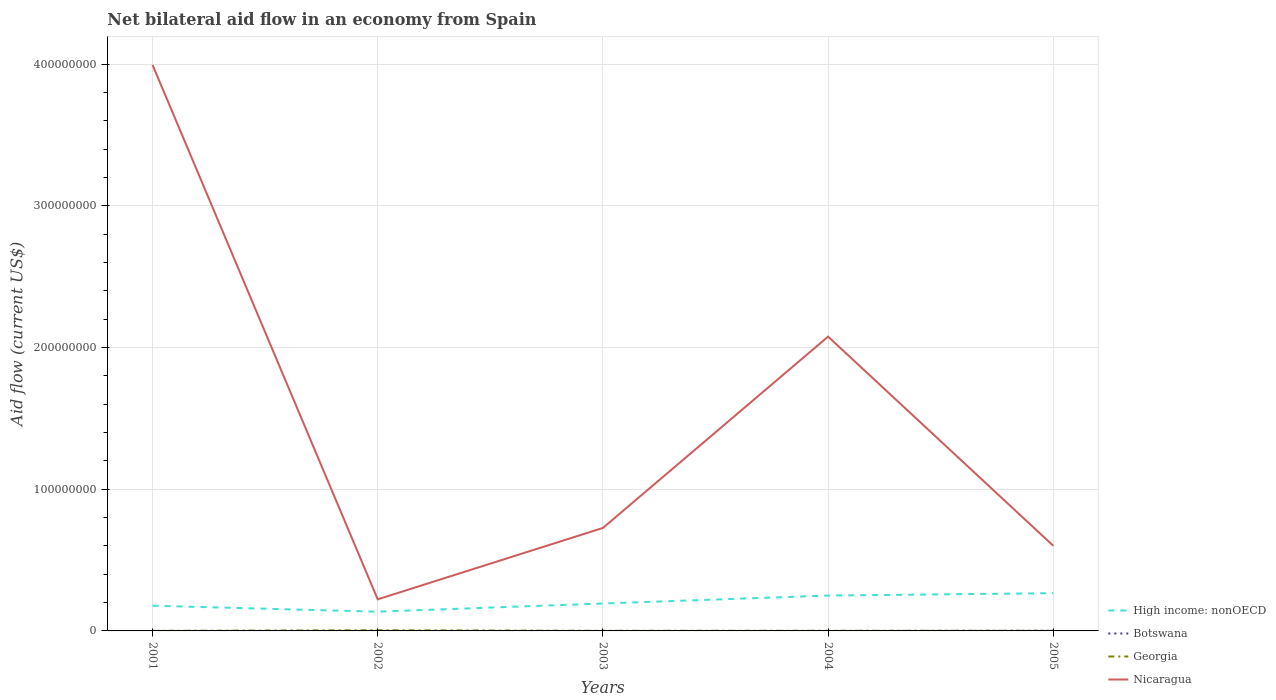How many different coloured lines are there?
Your answer should be compact. 4. Does the line corresponding to Georgia intersect with the line corresponding to High income: nonOECD?
Your answer should be compact. No. Across all years, what is the maximum net bilateral aid flow in Nicaragua?
Provide a short and direct response. 2.23e+07. In which year was the net bilateral aid flow in High income: nonOECD maximum?
Offer a very short reply. 2002. What is the total net bilateral aid flow in Nicaragua in the graph?
Your answer should be compact. -5.04e+07. What is the difference between the highest and the second highest net bilateral aid flow in Georgia?
Your answer should be compact. 4.10e+05. How many lines are there?
Your response must be concise. 4. What is the difference between two consecutive major ticks on the Y-axis?
Your answer should be very brief. 1.00e+08. Are the values on the major ticks of Y-axis written in scientific E-notation?
Provide a short and direct response. No. Does the graph contain grids?
Provide a succinct answer. Yes. How many legend labels are there?
Your answer should be very brief. 4. What is the title of the graph?
Give a very brief answer. Net bilateral aid flow in an economy from Spain. What is the label or title of the Y-axis?
Ensure brevity in your answer.  Aid flow (current US$). What is the Aid flow (current US$) of High income: nonOECD in 2001?
Offer a terse response. 1.78e+07. What is the Aid flow (current US$) of Botswana in 2001?
Your response must be concise. 10000. What is the Aid flow (current US$) in Georgia in 2001?
Keep it short and to the point. 5.00e+04. What is the Aid flow (current US$) of Nicaragua in 2001?
Your response must be concise. 3.99e+08. What is the Aid flow (current US$) of High income: nonOECD in 2002?
Your answer should be compact. 1.36e+07. What is the Aid flow (current US$) of Nicaragua in 2002?
Offer a very short reply. 2.23e+07. What is the Aid flow (current US$) of High income: nonOECD in 2003?
Offer a terse response. 1.94e+07. What is the Aid flow (current US$) of Georgia in 2003?
Keep it short and to the point. 8.00e+04. What is the Aid flow (current US$) of Nicaragua in 2003?
Provide a succinct answer. 7.27e+07. What is the Aid flow (current US$) of High income: nonOECD in 2004?
Offer a very short reply. 2.50e+07. What is the Aid flow (current US$) in Georgia in 2004?
Offer a terse response. 9.00e+04. What is the Aid flow (current US$) of Nicaragua in 2004?
Offer a terse response. 2.08e+08. What is the Aid flow (current US$) in High income: nonOECD in 2005?
Make the answer very short. 2.66e+07. What is the Aid flow (current US$) of Botswana in 2005?
Your answer should be compact. 1.50e+05. What is the Aid flow (current US$) of Nicaragua in 2005?
Make the answer very short. 6.01e+07. Across all years, what is the maximum Aid flow (current US$) in High income: nonOECD?
Your answer should be compact. 2.66e+07. Across all years, what is the maximum Aid flow (current US$) in Georgia?
Provide a succinct answer. 4.60e+05. Across all years, what is the maximum Aid flow (current US$) in Nicaragua?
Provide a succinct answer. 3.99e+08. Across all years, what is the minimum Aid flow (current US$) of High income: nonOECD?
Provide a short and direct response. 1.36e+07. Across all years, what is the minimum Aid flow (current US$) in Nicaragua?
Offer a very short reply. 2.23e+07. What is the total Aid flow (current US$) of High income: nonOECD in the graph?
Give a very brief answer. 1.02e+08. What is the total Aid flow (current US$) of Botswana in the graph?
Offer a terse response. 1.90e+05. What is the total Aid flow (current US$) of Georgia in the graph?
Offer a very short reply. 7.80e+05. What is the total Aid flow (current US$) in Nicaragua in the graph?
Make the answer very short. 7.62e+08. What is the difference between the Aid flow (current US$) of High income: nonOECD in 2001 and that in 2002?
Your answer should be compact. 4.22e+06. What is the difference between the Aid flow (current US$) in Botswana in 2001 and that in 2002?
Give a very brief answer. 0. What is the difference between the Aid flow (current US$) of Georgia in 2001 and that in 2002?
Your answer should be very brief. -4.10e+05. What is the difference between the Aid flow (current US$) in Nicaragua in 2001 and that in 2002?
Ensure brevity in your answer.  3.77e+08. What is the difference between the Aid flow (current US$) of High income: nonOECD in 2001 and that in 2003?
Provide a short and direct response. -1.57e+06. What is the difference between the Aid flow (current US$) in Nicaragua in 2001 and that in 2003?
Your answer should be compact. 3.27e+08. What is the difference between the Aid flow (current US$) in High income: nonOECD in 2001 and that in 2004?
Your answer should be compact. -7.16e+06. What is the difference between the Aid flow (current US$) of Botswana in 2001 and that in 2004?
Provide a succinct answer. 0. What is the difference between the Aid flow (current US$) in Nicaragua in 2001 and that in 2004?
Your answer should be very brief. 1.92e+08. What is the difference between the Aid flow (current US$) in High income: nonOECD in 2001 and that in 2005?
Make the answer very short. -8.86e+06. What is the difference between the Aid flow (current US$) of Botswana in 2001 and that in 2005?
Your answer should be compact. -1.40e+05. What is the difference between the Aid flow (current US$) in Georgia in 2001 and that in 2005?
Your response must be concise. -5.00e+04. What is the difference between the Aid flow (current US$) of Nicaragua in 2001 and that in 2005?
Provide a succinct answer. 3.39e+08. What is the difference between the Aid flow (current US$) of High income: nonOECD in 2002 and that in 2003?
Provide a succinct answer. -5.79e+06. What is the difference between the Aid flow (current US$) in Botswana in 2002 and that in 2003?
Provide a succinct answer. 0. What is the difference between the Aid flow (current US$) of Georgia in 2002 and that in 2003?
Provide a succinct answer. 3.80e+05. What is the difference between the Aid flow (current US$) in Nicaragua in 2002 and that in 2003?
Give a very brief answer. -5.04e+07. What is the difference between the Aid flow (current US$) of High income: nonOECD in 2002 and that in 2004?
Make the answer very short. -1.14e+07. What is the difference between the Aid flow (current US$) in Botswana in 2002 and that in 2004?
Provide a short and direct response. 0. What is the difference between the Aid flow (current US$) in Georgia in 2002 and that in 2004?
Your answer should be compact. 3.70e+05. What is the difference between the Aid flow (current US$) of Nicaragua in 2002 and that in 2004?
Your answer should be very brief. -1.85e+08. What is the difference between the Aid flow (current US$) in High income: nonOECD in 2002 and that in 2005?
Offer a terse response. -1.31e+07. What is the difference between the Aid flow (current US$) of Nicaragua in 2002 and that in 2005?
Your answer should be very brief. -3.78e+07. What is the difference between the Aid flow (current US$) in High income: nonOECD in 2003 and that in 2004?
Your response must be concise. -5.59e+06. What is the difference between the Aid flow (current US$) in Nicaragua in 2003 and that in 2004?
Provide a short and direct response. -1.35e+08. What is the difference between the Aid flow (current US$) in High income: nonOECD in 2003 and that in 2005?
Make the answer very short. -7.29e+06. What is the difference between the Aid flow (current US$) in Botswana in 2003 and that in 2005?
Offer a terse response. -1.40e+05. What is the difference between the Aid flow (current US$) in Nicaragua in 2003 and that in 2005?
Offer a very short reply. 1.26e+07. What is the difference between the Aid flow (current US$) of High income: nonOECD in 2004 and that in 2005?
Offer a very short reply. -1.70e+06. What is the difference between the Aid flow (current US$) of Botswana in 2004 and that in 2005?
Ensure brevity in your answer.  -1.40e+05. What is the difference between the Aid flow (current US$) of Georgia in 2004 and that in 2005?
Your answer should be very brief. -10000. What is the difference between the Aid flow (current US$) in Nicaragua in 2004 and that in 2005?
Ensure brevity in your answer.  1.48e+08. What is the difference between the Aid flow (current US$) in High income: nonOECD in 2001 and the Aid flow (current US$) in Botswana in 2002?
Ensure brevity in your answer.  1.78e+07. What is the difference between the Aid flow (current US$) in High income: nonOECD in 2001 and the Aid flow (current US$) in Georgia in 2002?
Your answer should be very brief. 1.73e+07. What is the difference between the Aid flow (current US$) in High income: nonOECD in 2001 and the Aid flow (current US$) in Nicaragua in 2002?
Ensure brevity in your answer.  -4.50e+06. What is the difference between the Aid flow (current US$) of Botswana in 2001 and the Aid flow (current US$) of Georgia in 2002?
Keep it short and to the point. -4.50e+05. What is the difference between the Aid flow (current US$) in Botswana in 2001 and the Aid flow (current US$) in Nicaragua in 2002?
Keep it short and to the point. -2.23e+07. What is the difference between the Aid flow (current US$) of Georgia in 2001 and the Aid flow (current US$) of Nicaragua in 2002?
Your answer should be compact. -2.22e+07. What is the difference between the Aid flow (current US$) in High income: nonOECD in 2001 and the Aid flow (current US$) in Botswana in 2003?
Ensure brevity in your answer.  1.78e+07. What is the difference between the Aid flow (current US$) of High income: nonOECD in 2001 and the Aid flow (current US$) of Georgia in 2003?
Give a very brief answer. 1.77e+07. What is the difference between the Aid flow (current US$) in High income: nonOECD in 2001 and the Aid flow (current US$) in Nicaragua in 2003?
Your response must be concise. -5.49e+07. What is the difference between the Aid flow (current US$) in Botswana in 2001 and the Aid flow (current US$) in Nicaragua in 2003?
Your answer should be very brief. -7.27e+07. What is the difference between the Aid flow (current US$) in Georgia in 2001 and the Aid flow (current US$) in Nicaragua in 2003?
Give a very brief answer. -7.26e+07. What is the difference between the Aid flow (current US$) in High income: nonOECD in 2001 and the Aid flow (current US$) in Botswana in 2004?
Ensure brevity in your answer.  1.78e+07. What is the difference between the Aid flow (current US$) in High income: nonOECD in 2001 and the Aid flow (current US$) in Georgia in 2004?
Ensure brevity in your answer.  1.77e+07. What is the difference between the Aid flow (current US$) in High income: nonOECD in 2001 and the Aid flow (current US$) in Nicaragua in 2004?
Provide a short and direct response. -1.90e+08. What is the difference between the Aid flow (current US$) of Botswana in 2001 and the Aid flow (current US$) of Nicaragua in 2004?
Provide a short and direct response. -2.08e+08. What is the difference between the Aid flow (current US$) in Georgia in 2001 and the Aid flow (current US$) in Nicaragua in 2004?
Give a very brief answer. -2.08e+08. What is the difference between the Aid flow (current US$) in High income: nonOECD in 2001 and the Aid flow (current US$) in Botswana in 2005?
Keep it short and to the point. 1.76e+07. What is the difference between the Aid flow (current US$) of High income: nonOECD in 2001 and the Aid flow (current US$) of Georgia in 2005?
Provide a short and direct response. 1.77e+07. What is the difference between the Aid flow (current US$) in High income: nonOECD in 2001 and the Aid flow (current US$) in Nicaragua in 2005?
Give a very brief answer. -4.23e+07. What is the difference between the Aid flow (current US$) of Botswana in 2001 and the Aid flow (current US$) of Georgia in 2005?
Your answer should be compact. -9.00e+04. What is the difference between the Aid flow (current US$) of Botswana in 2001 and the Aid flow (current US$) of Nicaragua in 2005?
Offer a terse response. -6.01e+07. What is the difference between the Aid flow (current US$) of Georgia in 2001 and the Aid flow (current US$) of Nicaragua in 2005?
Make the answer very short. -6.00e+07. What is the difference between the Aid flow (current US$) of High income: nonOECD in 2002 and the Aid flow (current US$) of Botswana in 2003?
Offer a terse response. 1.36e+07. What is the difference between the Aid flow (current US$) of High income: nonOECD in 2002 and the Aid flow (current US$) of Georgia in 2003?
Provide a succinct answer. 1.35e+07. What is the difference between the Aid flow (current US$) of High income: nonOECD in 2002 and the Aid flow (current US$) of Nicaragua in 2003?
Provide a short and direct response. -5.91e+07. What is the difference between the Aid flow (current US$) of Botswana in 2002 and the Aid flow (current US$) of Nicaragua in 2003?
Provide a succinct answer. -7.27e+07. What is the difference between the Aid flow (current US$) in Georgia in 2002 and the Aid flow (current US$) in Nicaragua in 2003?
Make the answer very short. -7.22e+07. What is the difference between the Aid flow (current US$) of High income: nonOECD in 2002 and the Aid flow (current US$) of Botswana in 2004?
Your response must be concise. 1.36e+07. What is the difference between the Aid flow (current US$) in High income: nonOECD in 2002 and the Aid flow (current US$) in Georgia in 2004?
Offer a very short reply. 1.35e+07. What is the difference between the Aid flow (current US$) in High income: nonOECD in 2002 and the Aid flow (current US$) in Nicaragua in 2004?
Provide a short and direct response. -1.94e+08. What is the difference between the Aid flow (current US$) of Botswana in 2002 and the Aid flow (current US$) of Nicaragua in 2004?
Your response must be concise. -2.08e+08. What is the difference between the Aid flow (current US$) of Georgia in 2002 and the Aid flow (current US$) of Nicaragua in 2004?
Make the answer very short. -2.07e+08. What is the difference between the Aid flow (current US$) in High income: nonOECD in 2002 and the Aid flow (current US$) in Botswana in 2005?
Ensure brevity in your answer.  1.34e+07. What is the difference between the Aid flow (current US$) of High income: nonOECD in 2002 and the Aid flow (current US$) of Georgia in 2005?
Give a very brief answer. 1.35e+07. What is the difference between the Aid flow (current US$) of High income: nonOECD in 2002 and the Aid flow (current US$) of Nicaragua in 2005?
Keep it short and to the point. -4.65e+07. What is the difference between the Aid flow (current US$) in Botswana in 2002 and the Aid flow (current US$) in Nicaragua in 2005?
Offer a very short reply. -6.01e+07. What is the difference between the Aid flow (current US$) of Georgia in 2002 and the Aid flow (current US$) of Nicaragua in 2005?
Give a very brief answer. -5.96e+07. What is the difference between the Aid flow (current US$) in High income: nonOECD in 2003 and the Aid flow (current US$) in Botswana in 2004?
Offer a very short reply. 1.94e+07. What is the difference between the Aid flow (current US$) of High income: nonOECD in 2003 and the Aid flow (current US$) of Georgia in 2004?
Offer a terse response. 1.93e+07. What is the difference between the Aid flow (current US$) in High income: nonOECD in 2003 and the Aid flow (current US$) in Nicaragua in 2004?
Keep it short and to the point. -1.88e+08. What is the difference between the Aid flow (current US$) of Botswana in 2003 and the Aid flow (current US$) of Nicaragua in 2004?
Ensure brevity in your answer.  -2.08e+08. What is the difference between the Aid flow (current US$) of Georgia in 2003 and the Aid flow (current US$) of Nicaragua in 2004?
Keep it short and to the point. -2.08e+08. What is the difference between the Aid flow (current US$) in High income: nonOECD in 2003 and the Aid flow (current US$) in Botswana in 2005?
Your answer should be very brief. 1.92e+07. What is the difference between the Aid flow (current US$) in High income: nonOECD in 2003 and the Aid flow (current US$) in Georgia in 2005?
Make the answer very short. 1.93e+07. What is the difference between the Aid flow (current US$) of High income: nonOECD in 2003 and the Aid flow (current US$) of Nicaragua in 2005?
Your response must be concise. -4.07e+07. What is the difference between the Aid flow (current US$) of Botswana in 2003 and the Aid flow (current US$) of Georgia in 2005?
Offer a very short reply. -9.00e+04. What is the difference between the Aid flow (current US$) of Botswana in 2003 and the Aid flow (current US$) of Nicaragua in 2005?
Offer a very short reply. -6.01e+07. What is the difference between the Aid flow (current US$) of Georgia in 2003 and the Aid flow (current US$) of Nicaragua in 2005?
Give a very brief answer. -6.00e+07. What is the difference between the Aid flow (current US$) of High income: nonOECD in 2004 and the Aid flow (current US$) of Botswana in 2005?
Give a very brief answer. 2.48e+07. What is the difference between the Aid flow (current US$) of High income: nonOECD in 2004 and the Aid flow (current US$) of Georgia in 2005?
Make the answer very short. 2.48e+07. What is the difference between the Aid flow (current US$) in High income: nonOECD in 2004 and the Aid flow (current US$) in Nicaragua in 2005?
Offer a very short reply. -3.51e+07. What is the difference between the Aid flow (current US$) in Botswana in 2004 and the Aid flow (current US$) in Nicaragua in 2005?
Offer a very short reply. -6.01e+07. What is the difference between the Aid flow (current US$) of Georgia in 2004 and the Aid flow (current US$) of Nicaragua in 2005?
Ensure brevity in your answer.  -6.00e+07. What is the average Aid flow (current US$) in High income: nonOECD per year?
Provide a short and direct response. 2.05e+07. What is the average Aid flow (current US$) in Botswana per year?
Give a very brief answer. 3.80e+04. What is the average Aid flow (current US$) of Georgia per year?
Provide a succinct answer. 1.56e+05. What is the average Aid flow (current US$) in Nicaragua per year?
Offer a very short reply. 1.52e+08. In the year 2001, what is the difference between the Aid flow (current US$) of High income: nonOECD and Aid flow (current US$) of Botswana?
Ensure brevity in your answer.  1.78e+07. In the year 2001, what is the difference between the Aid flow (current US$) of High income: nonOECD and Aid flow (current US$) of Georgia?
Make the answer very short. 1.77e+07. In the year 2001, what is the difference between the Aid flow (current US$) in High income: nonOECD and Aid flow (current US$) in Nicaragua?
Give a very brief answer. -3.82e+08. In the year 2001, what is the difference between the Aid flow (current US$) of Botswana and Aid flow (current US$) of Nicaragua?
Offer a very short reply. -3.99e+08. In the year 2001, what is the difference between the Aid flow (current US$) in Georgia and Aid flow (current US$) in Nicaragua?
Your answer should be very brief. -3.99e+08. In the year 2002, what is the difference between the Aid flow (current US$) of High income: nonOECD and Aid flow (current US$) of Botswana?
Your response must be concise. 1.36e+07. In the year 2002, what is the difference between the Aid flow (current US$) of High income: nonOECD and Aid flow (current US$) of Georgia?
Offer a terse response. 1.31e+07. In the year 2002, what is the difference between the Aid flow (current US$) of High income: nonOECD and Aid flow (current US$) of Nicaragua?
Provide a succinct answer. -8.72e+06. In the year 2002, what is the difference between the Aid flow (current US$) of Botswana and Aid flow (current US$) of Georgia?
Your response must be concise. -4.50e+05. In the year 2002, what is the difference between the Aid flow (current US$) of Botswana and Aid flow (current US$) of Nicaragua?
Your answer should be compact. -2.23e+07. In the year 2002, what is the difference between the Aid flow (current US$) of Georgia and Aid flow (current US$) of Nicaragua?
Provide a short and direct response. -2.18e+07. In the year 2003, what is the difference between the Aid flow (current US$) of High income: nonOECD and Aid flow (current US$) of Botswana?
Provide a short and direct response. 1.94e+07. In the year 2003, what is the difference between the Aid flow (current US$) of High income: nonOECD and Aid flow (current US$) of Georgia?
Your answer should be compact. 1.93e+07. In the year 2003, what is the difference between the Aid flow (current US$) of High income: nonOECD and Aid flow (current US$) of Nicaragua?
Keep it short and to the point. -5.33e+07. In the year 2003, what is the difference between the Aid flow (current US$) of Botswana and Aid flow (current US$) of Georgia?
Ensure brevity in your answer.  -7.00e+04. In the year 2003, what is the difference between the Aid flow (current US$) in Botswana and Aid flow (current US$) in Nicaragua?
Your answer should be very brief. -7.27e+07. In the year 2003, what is the difference between the Aid flow (current US$) in Georgia and Aid flow (current US$) in Nicaragua?
Offer a terse response. -7.26e+07. In the year 2004, what is the difference between the Aid flow (current US$) of High income: nonOECD and Aid flow (current US$) of Botswana?
Your response must be concise. 2.49e+07. In the year 2004, what is the difference between the Aid flow (current US$) of High income: nonOECD and Aid flow (current US$) of Georgia?
Your response must be concise. 2.49e+07. In the year 2004, what is the difference between the Aid flow (current US$) in High income: nonOECD and Aid flow (current US$) in Nicaragua?
Give a very brief answer. -1.83e+08. In the year 2004, what is the difference between the Aid flow (current US$) of Botswana and Aid flow (current US$) of Georgia?
Ensure brevity in your answer.  -8.00e+04. In the year 2004, what is the difference between the Aid flow (current US$) in Botswana and Aid flow (current US$) in Nicaragua?
Offer a terse response. -2.08e+08. In the year 2004, what is the difference between the Aid flow (current US$) in Georgia and Aid flow (current US$) in Nicaragua?
Provide a short and direct response. -2.08e+08. In the year 2005, what is the difference between the Aid flow (current US$) of High income: nonOECD and Aid flow (current US$) of Botswana?
Make the answer very short. 2.65e+07. In the year 2005, what is the difference between the Aid flow (current US$) of High income: nonOECD and Aid flow (current US$) of Georgia?
Your answer should be compact. 2.66e+07. In the year 2005, what is the difference between the Aid flow (current US$) of High income: nonOECD and Aid flow (current US$) of Nicaragua?
Offer a very short reply. -3.34e+07. In the year 2005, what is the difference between the Aid flow (current US$) of Botswana and Aid flow (current US$) of Nicaragua?
Make the answer very short. -5.99e+07. In the year 2005, what is the difference between the Aid flow (current US$) in Georgia and Aid flow (current US$) in Nicaragua?
Offer a terse response. -6.00e+07. What is the ratio of the Aid flow (current US$) in High income: nonOECD in 2001 to that in 2002?
Your answer should be compact. 1.31. What is the ratio of the Aid flow (current US$) in Botswana in 2001 to that in 2002?
Offer a terse response. 1. What is the ratio of the Aid flow (current US$) of Georgia in 2001 to that in 2002?
Provide a short and direct response. 0.11. What is the ratio of the Aid flow (current US$) of Nicaragua in 2001 to that in 2002?
Your answer should be very brief. 17.92. What is the ratio of the Aid flow (current US$) of High income: nonOECD in 2001 to that in 2003?
Offer a terse response. 0.92. What is the ratio of the Aid flow (current US$) of Botswana in 2001 to that in 2003?
Ensure brevity in your answer.  1. What is the ratio of the Aid flow (current US$) in Georgia in 2001 to that in 2003?
Make the answer very short. 0.62. What is the ratio of the Aid flow (current US$) in Nicaragua in 2001 to that in 2003?
Your answer should be compact. 5.5. What is the ratio of the Aid flow (current US$) in High income: nonOECD in 2001 to that in 2004?
Ensure brevity in your answer.  0.71. What is the ratio of the Aid flow (current US$) in Georgia in 2001 to that in 2004?
Provide a succinct answer. 0.56. What is the ratio of the Aid flow (current US$) of Nicaragua in 2001 to that in 2004?
Ensure brevity in your answer.  1.92. What is the ratio of the Aid flow (current US$) of High income: nonOECD in 2001 to that in 2005?
Your answer should be very brief. 0.67. What is the ratio of the Aid flow (current US$) in Botswana in 2001 to that in 2005?
Offer a very short reply. 0.07. What is the ratio of the Aid flow (current US$) of Georgia in 2001 to that in 2005?
Offer a very short reply. 0.5. What is the ratio of the Aid flow (current US$) in Nicaragua in 2001 to that in 2005?
Give a very brief answer. 6.65. What is the ratio of the Aid flow (current US$) in High income: nonOECD in 2002 to that in 2003?
Provide a succinct answer. 0.7. What is the ratio of the Aid flow (current US$) in Botswana in 2002 to that in 2003?
Offer a very short reply. 1. What is the ratio of the Aid flow (current US$) in Georgia in 2002 to that in 2003?
Give a very brief answer. 5.75. What is the ratio of the Aid flow (current US$) in Nicaragua in 2002 to that in 2003?
Make the answer very short. 0.31. What is the ratio of the Aid flow (current US$) in High income: nonOECD in 2002 to that in 2004?
Your answer should be compact. 0.54. What is the ratio of the Aid flow (current US$) of Georgia in 2002 to that in 2004?
Give a very brief answer. 5.11. What is the ratio of the Aid flow (current US$) of Nicaragua in 2002 to that in 2004?
Offer a terse response. 0.11. What is the ratio of the Aid flow (current US$) of High income: nonOECD in 2002 to that in 2005?
Provide a short and direct response. 0.51. What is the ratio of the Aid flow (current US$) in Botswana in 2002 to that in 2005?
Make the answer very short. 0.07. What is the ratio of the Aid flow (current US$) in Nicaragua in 2002 to that in 2005?
Make the answer very short. 0.37. What is the ratio of the Aid flow (current US$) in High income: nonOECD in 2003 to that in 2004?
Keep it short and to the point. 0.78. What is the ratio of the Aid flow (current US$) of Botswana in 2003 to that in 2004?
Provide a succinct answer. 1. What is the ratio of the Aid flow (current US$) of Nicaragua in 2003 to that in 2004?
Give a very brief answer. 0.35. What is the ratio of the Aid flow (current US$) of High income: nonOECD in 2003 to that in 2005?
Provide a succinct answer. 0.73. What is the ratio of the Aid flow (current US$) in Botswana in 2003 to that in 2005?
Make the answer very short. 0.07. What is the ratio of the Aid flow (current US$) in Georgia in 2003 to that in 2005?
Provide a short and direct response. 0.8. What is the ratio of the Aid flow (current US$) in Nicaragua in 2003 to that in 2005?
Give a very brief answer. 1.21. What is the ratio of the Aid flow (current US$) of High income: nonOECD in 2004 to that in 2005?
Offer a very short reply. 0.94. What is the ratio of the Aid flow (current US$) of Botswana in 2004 to that in 2005?
Make the answer very short. 0.07. What is the ratio of the Aid flow (current US$) in Georgia in 2004 to that in 2005?
Offer a terse response. 0.9. What is the ratio of the Aid flow (current US$) of Nicaragua in 2004 to that in 2005?
Make the answer very short. 3.46. What is the difference between the highest and the second highest Aid flow (current US$) in High income: nonOECD?
Make the answer very short. 1.70e+06. What is the difference between the highest and the second highest Aid flow (current US$) of Botswana?
Your answer should be compact. 1.40e+05. What is the difference between the highest and the second highest Aid flow (current US$) in Nicaragua?
Offer a terse response. 1.92e+08. What is the difference between the highest and the lowest Aid flow (current US$) in High income: nonOECD?
Your answer should be very brief. 1.31e+07. What is the difference between the highest and the lowest Aid flow (current US$) of Botswana?
Offer a very short reply. 1.40e+05. What is the difference between the highest and the lowest Aid flow (current US$) of Georgia?
Offer a very short reply. 4.10e+05. What is the difference between the highest and the lowest Aid flow (current US$) in Nicaragua?
Your response must be concise. 3.77e+08. 